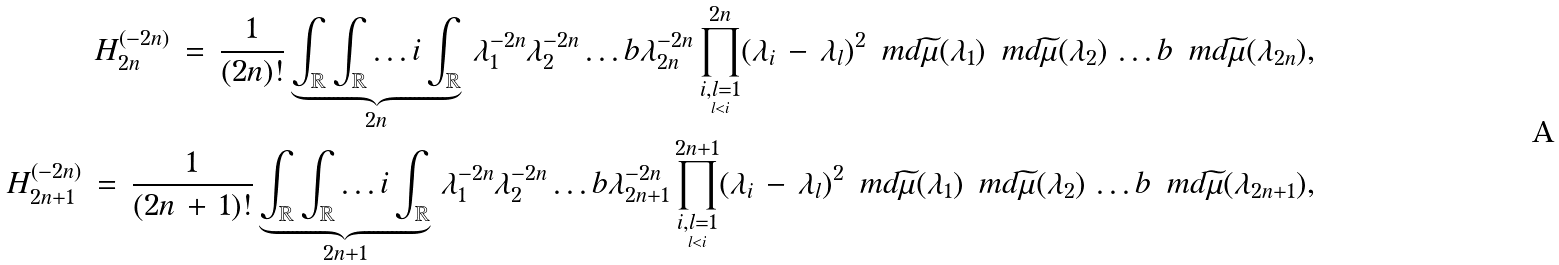<formula> <loc_0><loc_0><loc_500><loc_500>H ^ { ( - 2 n ) } _ { 2 n } \, = \, \frac { 1 } { ( 2 n ) ! } \underbrace { \int _ { \mathbb { R } } \int _ { \mathbb { R } } \dots i \int _ { \mathbb { R } } } _ { 2 n } \, \lambda _ { 1 } ^ { - 2 n } \lambda _ { 2 } ^ { - 2 n } \dots b \lambda _ { 2 n } ^ { - 2 n } \prod _ { \underset { l < i } { i , l = 1 } } ^ { 2 n } ( \lambda _ { i } \, - \, \lambda _ { l } ) ^ { 2 } \, \ m d \widetilde { \mu } ( \lambda _ { 1 } ) \, \ m d \widetilde { \mu } ( \lambda _ { 2 } ) \, \dots b \, \ m d \widetilde { \mu } ( \lambda _ { 2 n } ) , \\ H ^ { ( - 2 n ) } _ { 2 n + 1 } \, = \, \frac { 1 } { ( 2 n \, + \, 1 ) ! } \underbrace { \int _ { \mathbb { R } } \int _ { \mathbb { R } } \dots i \int _ { \mathbb { R } } } _ { 2 n + 1 } \, \lambda _ { 1 } ^ { - 2 n } \lambda _ { 2 } ^ { - 2 n } \dots b \lambda _ { 2 n + 1 } ^ { - 2 n } \prod _ { \underset { l < i } { i , l = 1 } } ^ { 2 n + 1 } ( \lambda _ { i } \, - \, \lambda _ { l } ) ^ { 2 } \, \ m d \widetilde { \mu } ( \lambda _ { 1 } ) \, \ m d \widetilde { \mu } ( \lambda _ { 2 } ) \, \dots b \, \ m d \widetilde { \mu } ( \lambda _ { 2 n + 1 } ) ,</formula> 